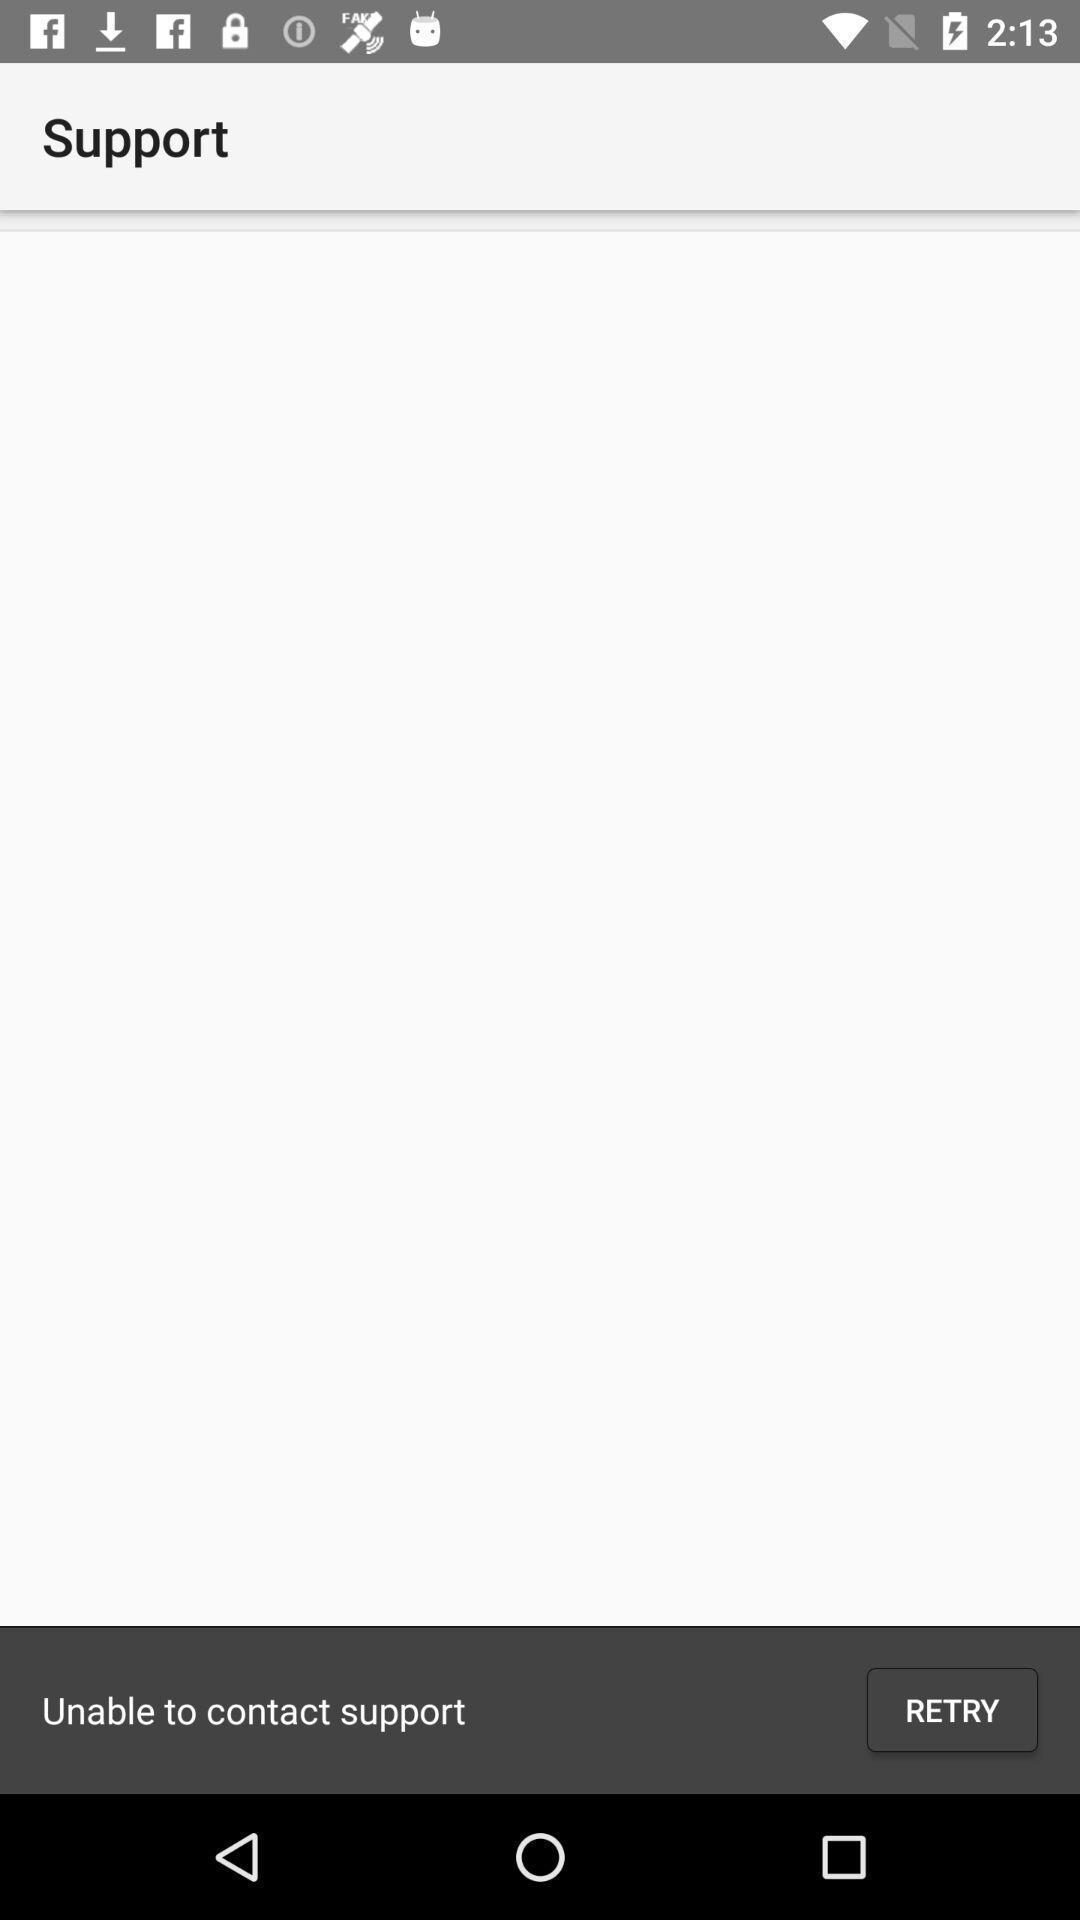Summarize the information in this screenshot. Page showing to retry a contact support. 